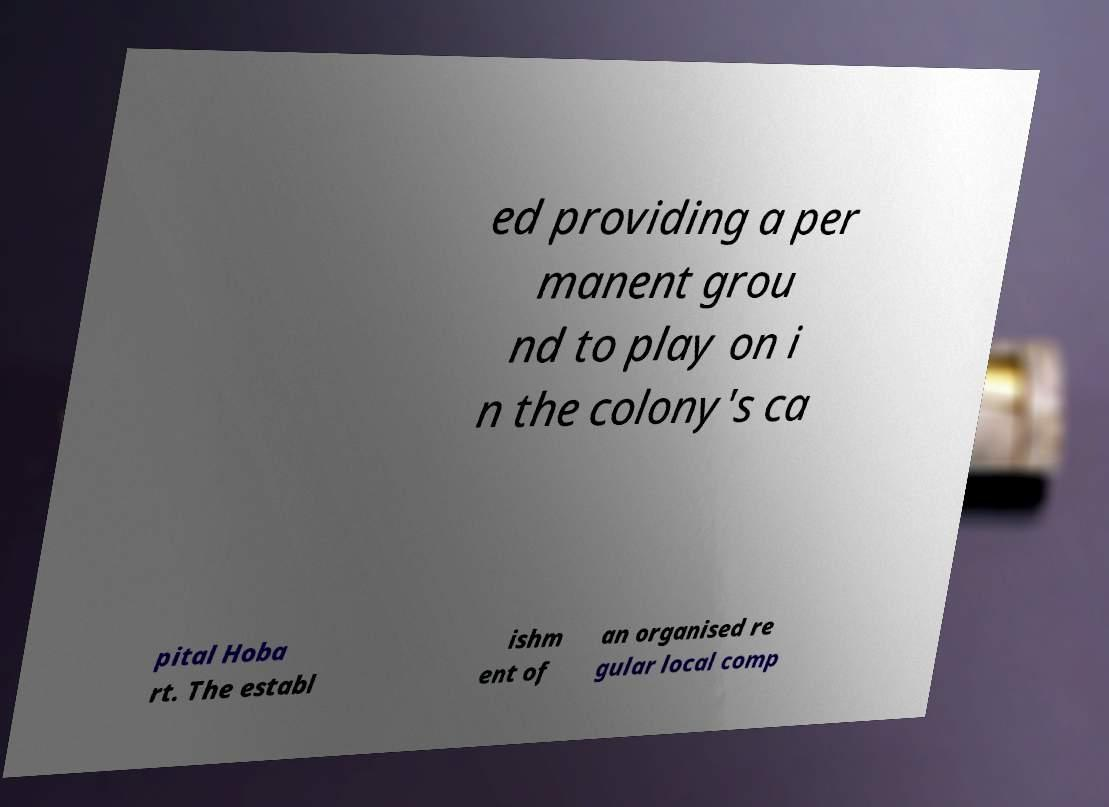There's text embedded in this image that I need extracted. Can you transcribe it verbatim? ed providing a per manent grou nd to play on i n the colony's ca pital Hoba rt. The establ ishm ent of an organised re gular local comp 